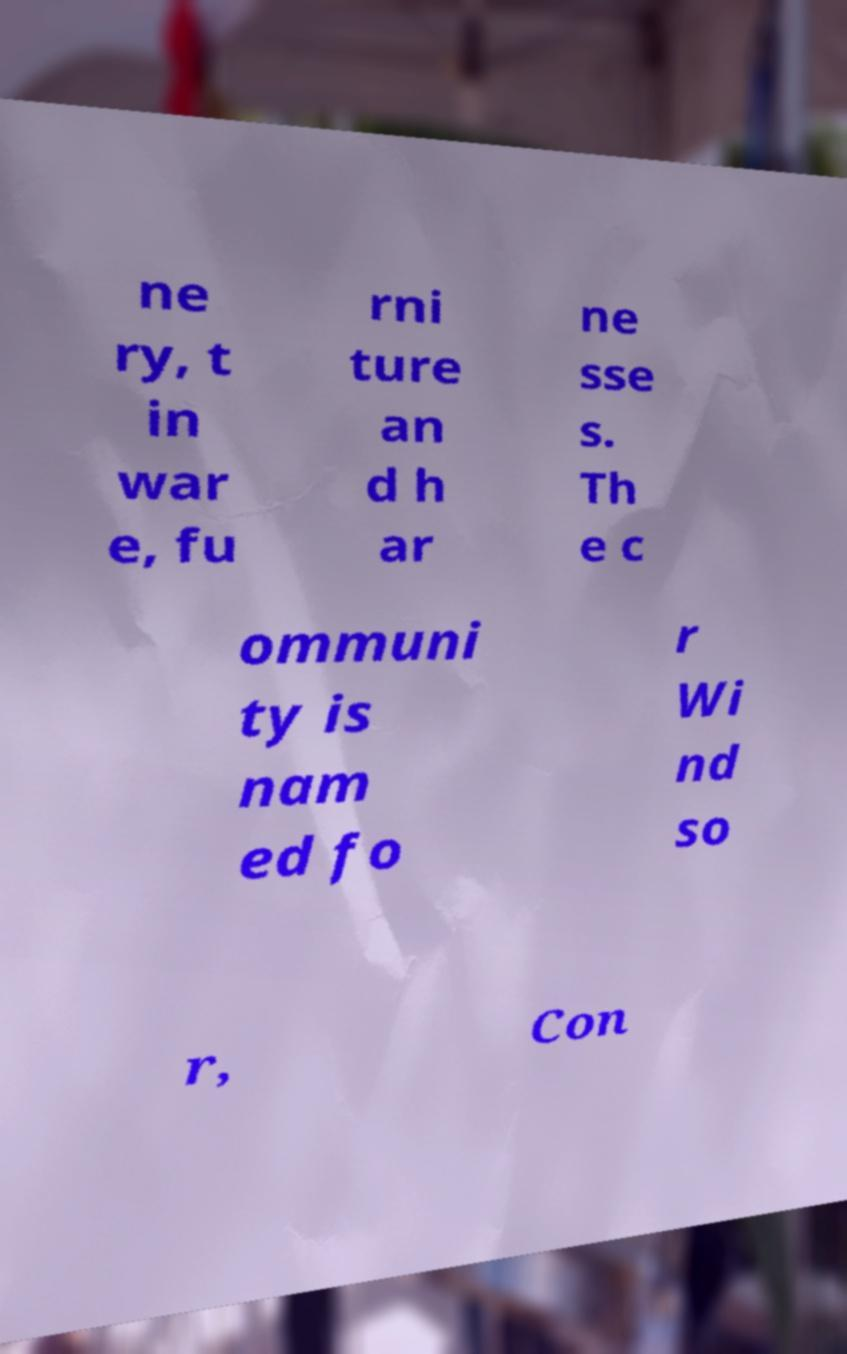I need the written content from this picture converted into text. Can you do that? ne ry, t in war e, fu rni ture an d h ar ne sse s. Th e c ommuni ty is nam ed fo r Wi nd so r, Con 